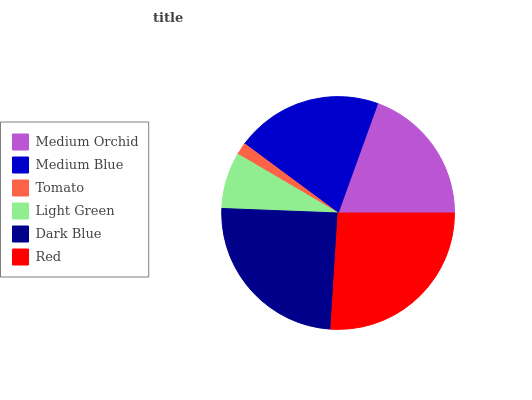Is Tomato the minimum?
Answer yes or no. Yes. Is Red the maximum?
Answer yes or no. Yes. Is Medium Blue the minimum?
Answer yes or no. No. Is Medium Blue the maximum?
Answer yes or no. No. Is Medium Blue greater than Medium Orchid?
Answer yes or no. Yes. Is Medium Orchid less than Medium Blue?
Answer yes or no. Yes. Is Medium Orchid greater than Medium Blue?
Answer yes or no. No. Is Medium Blue less than Medium Orchid?
Answer yes or no. No. Is Medium Blue the high median?
Answer yes or no. Yes. Is Medium Orchid the low median?
Answer yes or no. Yes. Is Dark Blue the high median?
Answer yes or no. No. Is Medium Blue the low median?
Answer yes or no. No. 